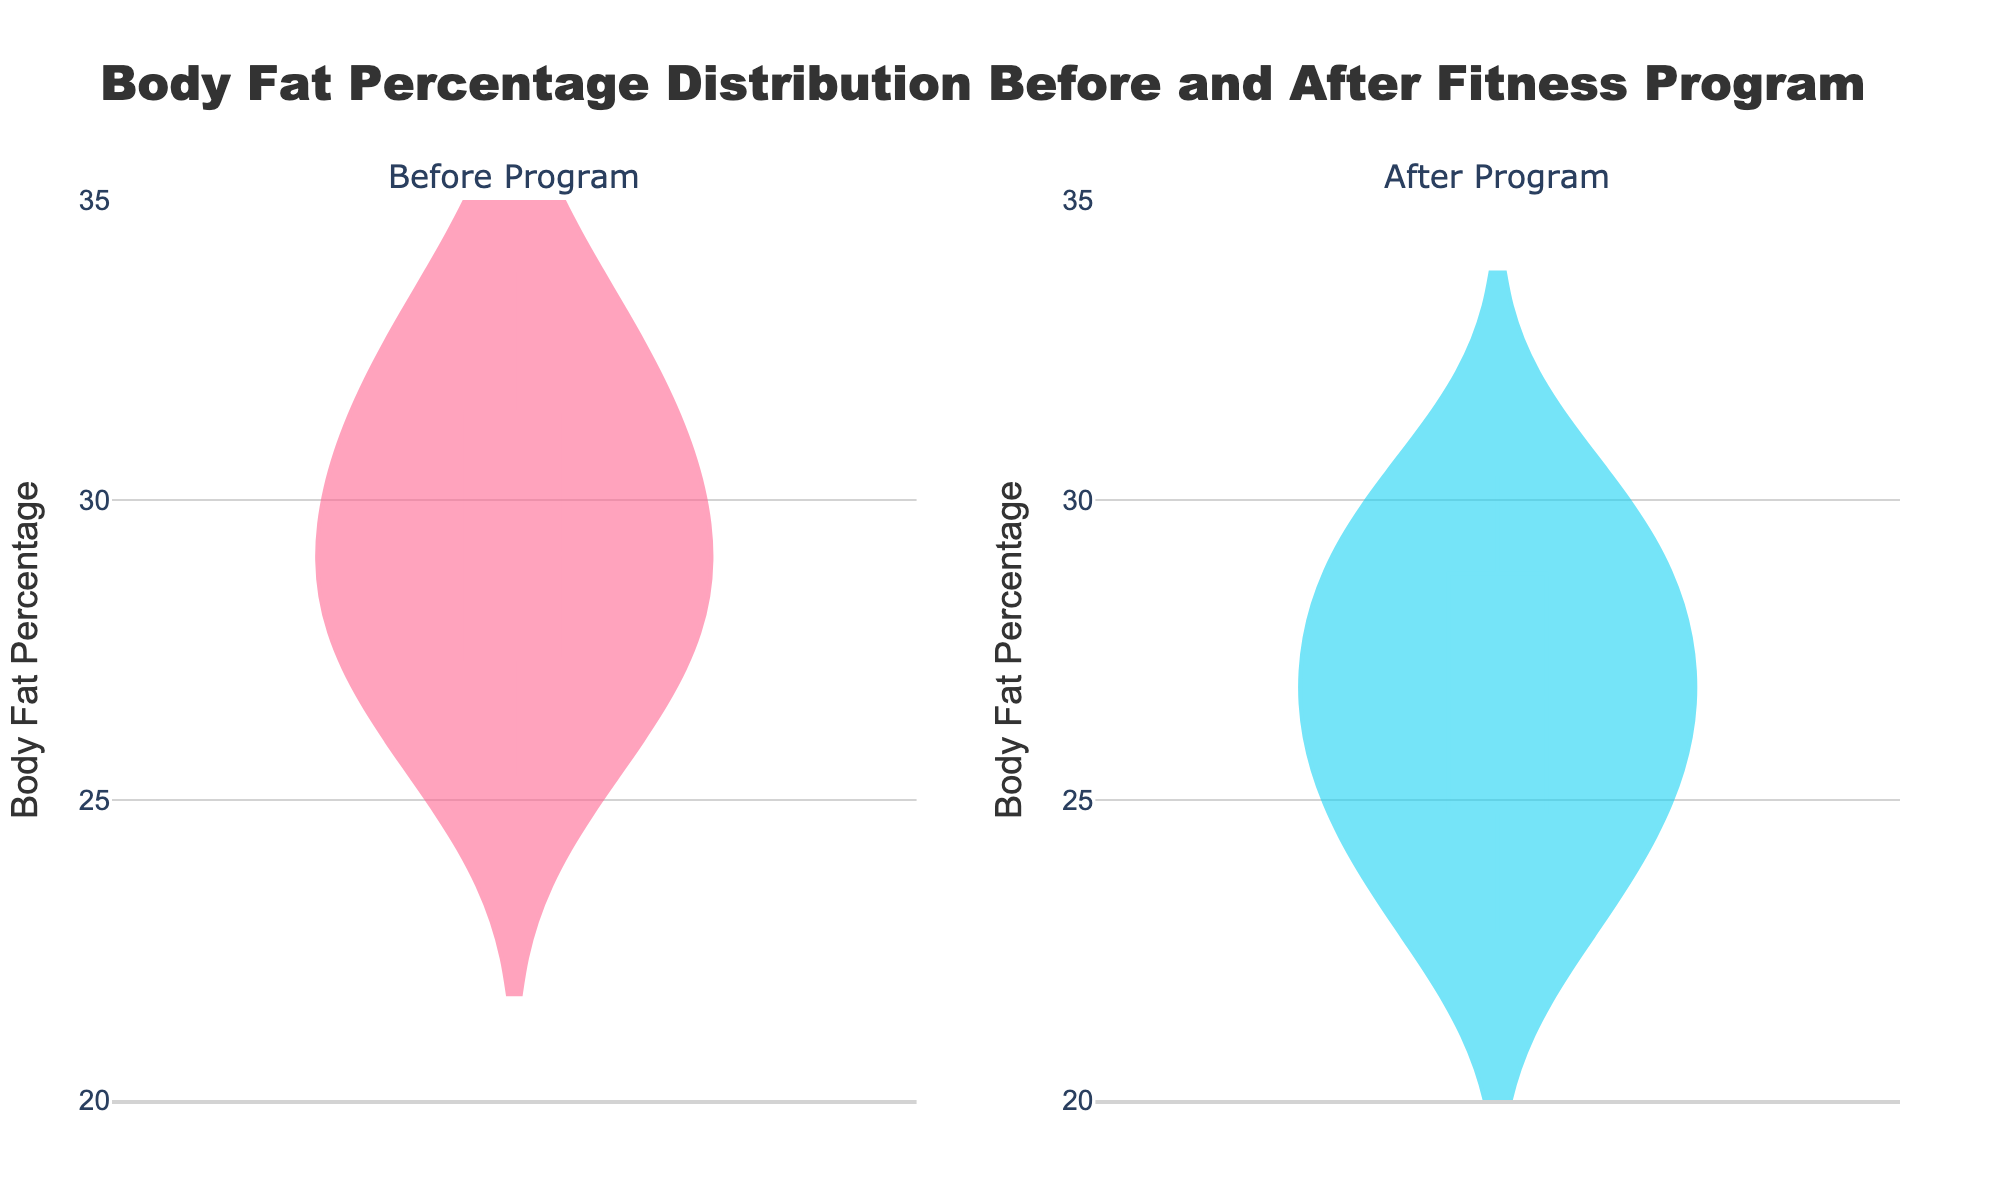What is the title of the figure? The title of the figure is displayed at the top and provides an overview of the data visualized.
Answer: Body Fat Percentage Distribution Before and After Fitness Program What are the colors used for the "Before" and "After" distributions? The color provides a visual distinction between the two groups. "Before" is in a certain color and "After" is in another.
Answer: "Before" is pinkish-red, "After" is light blue What is the range of the y-axis in the figure? The y-axis shows the Body Fat Percentage. Its range can be identified by looking at the axis labels.
Answer: 20 to 35 How many participants' data points are visualized in each distribution? The number of data points represents each participant's Body Fat Percentage before and after the program. Count the unique data points in each violin plot.
Answer: 8 What does the spread of the "Before" distribution suggest about the variability in body fat percentages? The "Before" distribution's spread indicates how body fat percentages vary among participants before the program. If the spread is wide, variability is high; if it's narrow, variability is low.
Answer: High variability What is the median Body Fat Percentage for participants after the program? The median is a statistical measure indicating the middle value of the dataset; in a violin plot, this is highlighted by a line within the interquartile range. Inspect the "After" violin plot for this line.
Answer: Approximately 26.4 How does the median Body Fat Percentage before the program compare to that after the program? Compare the locations of the median lines in both "Before" and "After" distributions to determine if one is higher or lower than the other.
Answer: The median before the program is higher than after What can be inferred about the effectiveness of the fitness program from this figure? To infer the effectiveness, observe the shift in distribution and median values, showing a decrease in Body Fat Percentage. A significant shift downwards suggests efficacy.
Answer: The program was effective in reducing body fat Which distribution (Before or After) shows more variability in Body Fat Percentage? Variability in a distribution can be assessed by the spread (width) of the violin plot. A wider plot indicates more variability.
Answer: Before Is there any overlap between the distributions of Body Fat Percentage before and after the program? Overlap refers to the extent to which the two distributions share common values. If both plots intersect or occupy similar y-values, there is overlap.
Answer: There is some overlap 